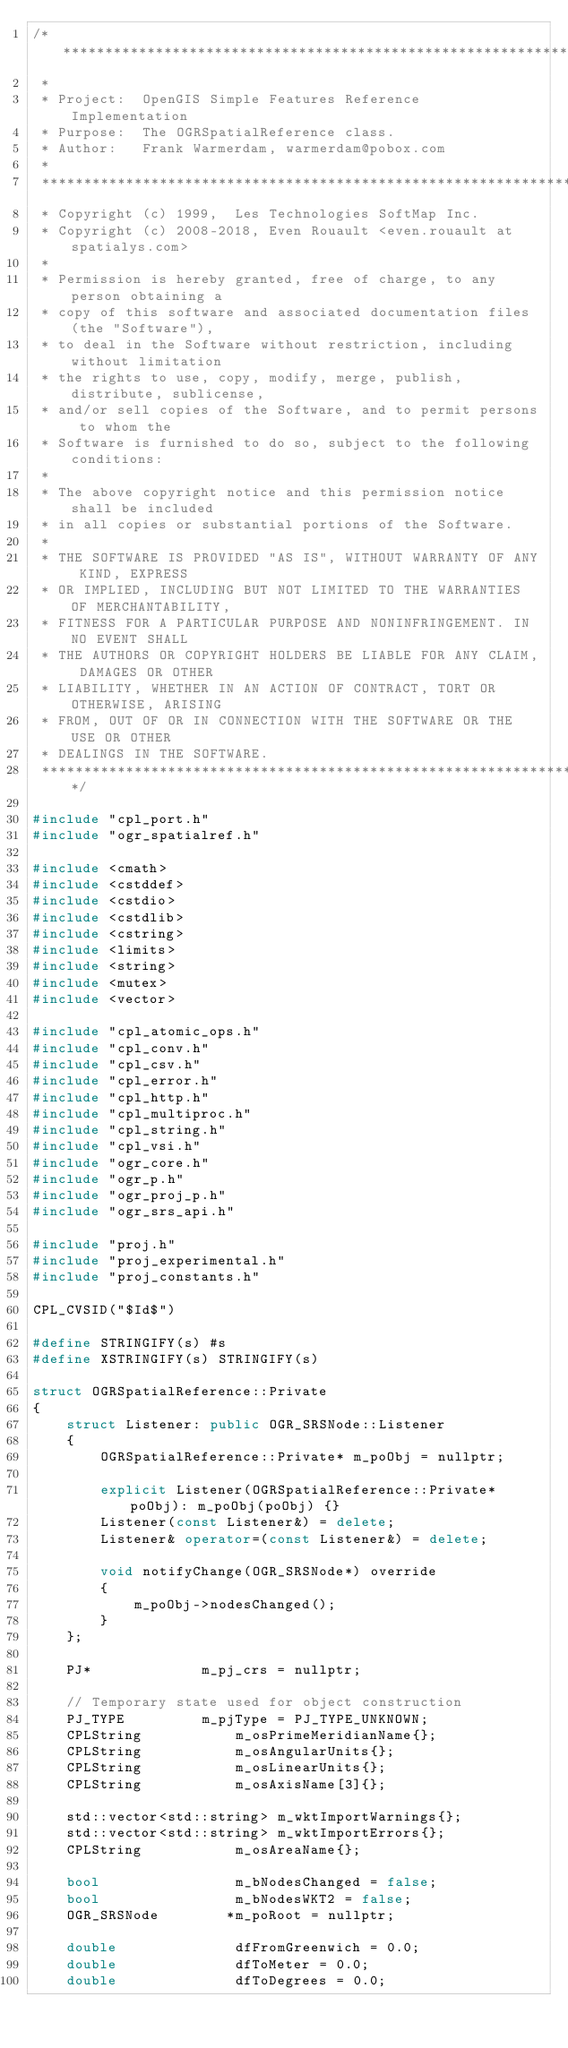Convert code to text. <code><loc_0><loc_0><loc_500><loc_500><_C++_>/******************************************************************************
 *
 * Project:  OpenGIS Simple Features Reference Implementation
 * Purpose:  The OGRSpatialReference class.
 * Author:   Frank Warmerdam, warmerdam@pobox.com
 *
 ******************************************************************************
 * Copyright (c) 1999,  Les Technologies SoftMap Inc.
 * Copyright (c) 2008-2018, Even Rouault <even.rouault at spatialys.com>
 *
 * Permission is hereby granted, free of charge, to any person obtaining a
 * copy of this software and associated documentation files (the "Software"),
 * to deal in the Software without restriction, including without limitation
 * the rights to use, copy, modify, merge, publish, distribute, sublicense,
 * and/or sell copies of the Software, and to permit persons to whom the
 * Software is furnished to do so, subject to the following conditions:
 *
 * The above copyright notice and this permission notice shall be included
 * in all copies or substantial portions of the Software.
 *
 * THE SOFTWARE IS PROVIDED "AS IS", WITHOUT WARRANTY OF ANY KIND, EXPRESS
 * OR IMPLIED, INCLUDING BUT NOT LIMITED TO THE WARRANTIES OF MERCHANTABILITY,
 * FITNESS FOR A PARTICULAR PURPOSE AND NONINFRINGEMENT. IN NO EVENT SHALL
 * THE AUTHORS OR COPYRIGHT HOLDERS BE LIABLE FOR ANY CLAIM, DAMAGES OR OTHER
 * LIABILITY, WHETHER IN AN ACTION OF CONTRACT, TORT OR OTHERWISE, ARISING
 * FROM, OUT OF OR IN CONNECTION WITH THE SOFTWARE OR THE USE OR OTHER
 * DEALINGS IN THE SOFTWARE.
 ****************************************************************************/

#include "cpl_port.h"
#include "ogr_spatialref.h"

#include <cmath>
#include <cstddef>
#include <cstdio>
#include <cstdlib>
#include <cstring>
#include <limits>
#include <string>
#include <mutex>
#include <vector>

#include "cpl_atomic_ops.h"
#include "cpl_conv.h"
#include "cpl_csv.h"
#include "cpl_error.h"
#include "cpl_http.h"
#include "cpl_multiproc.h"
#include "cpl_string.h"
#include "cpl_vsi.h"
#include "ogr_core.h"
#include "ogr_p.h"
#include "ogr_proj_p.h"
#include "ogr_srs_api.h"

#include "proj.h"
#include "proj_experimental.h"
#include "proj_constants.h"

CPL_CVSID("$Id$")

#define STRINGIFY(s) #s
#define XSTRINGIFY(s) STRINGIFY(s)

struct OGRSpatialReference::Private
{
    struct Listener: public OGR_SRSNode::Listener
    {
        OGRSpatialReference::Private* m_poObj = nullptr;

        explicit Listener(OGRSpatialReference::Private* poObj): m_poObj(poObj) {}
        Listener(const Listener&) = delete;
        Listener& operator=(const Listener&) = delete;

        void notifyChange(OGR_SRSNode*) override
        {
            m_poObj->nodesChanged();
        }
    };

    PJ*             m_pj_crs = nullptr;

    // Temporary state used for object construction
    PJ_TYPE         m_pjType = PJ_TYPE_UNKNOWN;
    CPLString           m_osPrimeMeridianName{};
    CPLString           m_osAngularUnits{};
    CPLString           m_osLinearUnits{};
    CPLString           m_osAxisName[3]{};

    std::vector<std::string> m_wktImportWarnings{};
    std::vector<std::string> m_wktImportErrors{};
    CPLString           m_osAreaName{};

    bool                m_bNodesChanged = false;
    bool                m_bNodesWKT2 = false;
    OGR_SRSNode        *m_poRoot = nullptr;

    double              dfFromGreenwich = 0.0;
    double              dfToMeter = 0.0;
    double              dfToDegrees = 0.0;</code> 